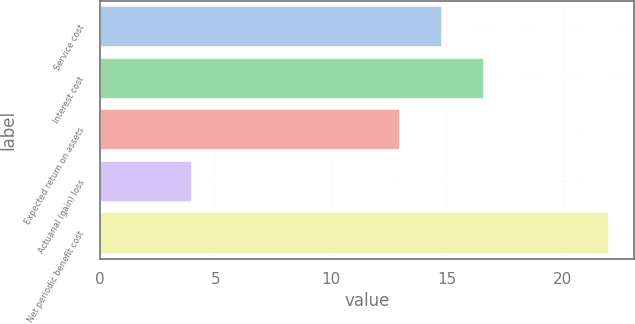<chart> <loc_0><loc_0><loc_500><loc_500><bar_chart><fcel>Service cost<fcel>Interest cost<fcel>Expected return on assets<fcel>Actuarial (gain) loss<fcel>Net periodic benefit cost<nl><fcel>14.8<fcel>16.6<fcel>13<fcel>4<fcel>22<nl></chart> 